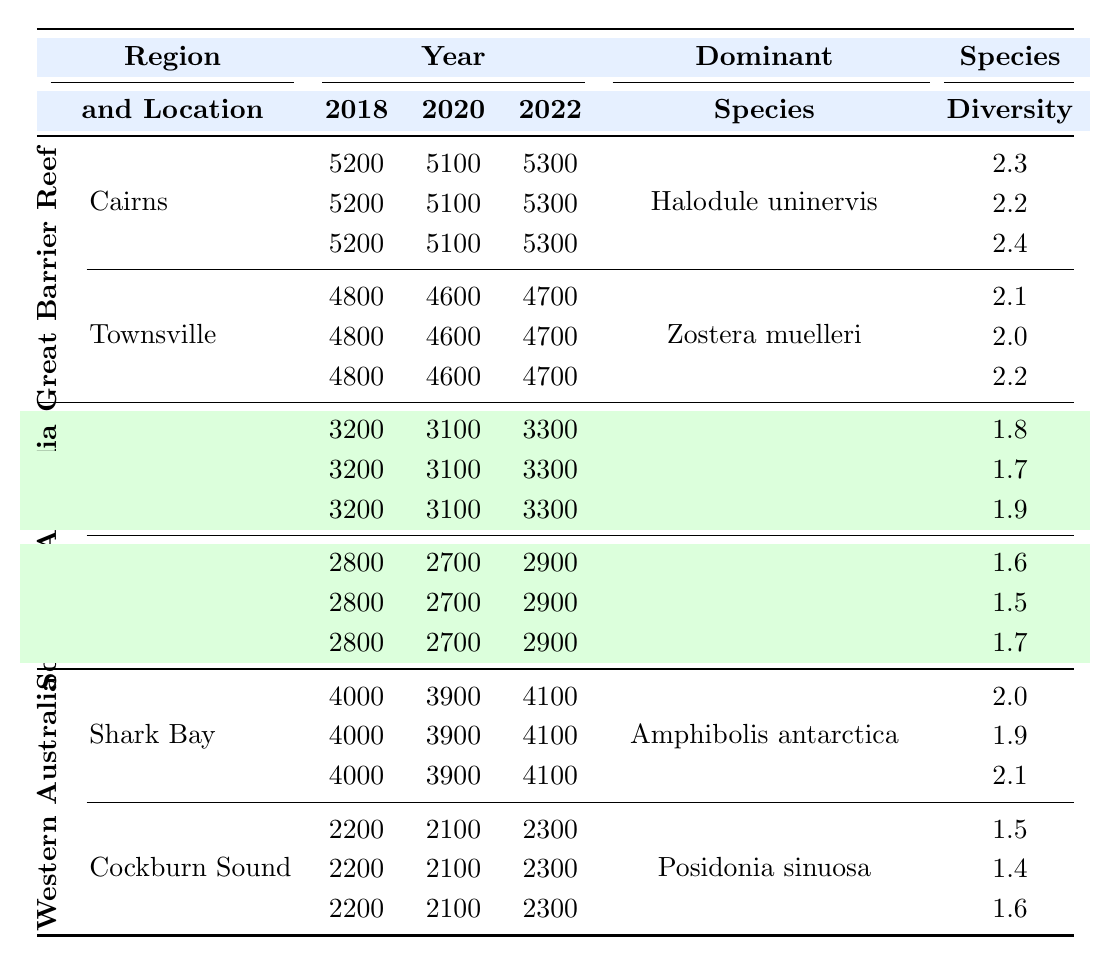What was the total coverage of seagrass in Cairns in 2022? The table shows that in Cairns, the total coverage of seagrass in 2022 was 5300 hectares.
Answer: 5300 hectares Which location had the highest species diversity index in 2020? By comparing the Species Diversity Index values listed for each location in 2020, Townsville had a value of 2.0, which is higher than Port Phillip Bay's 1.7 and Gulf St Vincent's 1.5. Therefore, Townsville had the highest species diversity index in 2020.
Answer: Townsville Is Halodule uninervis the dominant species in both Cairns and Townsville? The table indicates that Halodule uninervis is the dominant species in Cairns, but in Townsville, the dominant species is Zostera muelleri. Therefore, it is not true that Halodule uninervis is the dominant species in both locations.
Answer: No What is the average total coverage of seagrass in Shark Bay over the years surveyed? To find the average, sum the total coverage over the three years: 4000 + 3900 + 4100 = 12000. Then divide by the number of years (3): 12000 / 3 = 4000.
Answer: 4000 hectares How did the Species Diversity Index change from 2018 to 2022 in Port Phillip Bay? In 2018, the Species Diversity Index for Port Phillip Bay was 1.8. In 2022, it increased to 1.9. Hence, there is an increase of 0.1 over the period from 2018 to 2022.
Answer: Increased by 0.1 Which region experienced the greatest decrease in total seagrass coverage from 2018 to 2020? Looking at the table, the coverage for Southern Australia's Gulf St Vincent decreased from 2800 hectares in 2018 to 2700 hectares in 2020, resulting in a decrease of 100 hectares. This is more than the 100 hectares decrease in Cairns and Townsville, leading to the conclusion that Gulf St Vincent had the greatest decrease in total coverage.
Answer: Gulf St Vincent What can be inferred about the trends in total coverage of seagrass in Great Barrier Reef locations from 2018 to 2022? Examining the total coverage in Cairns and Townsville, Cairns showed a slight decline from 5200 hectares in 2018 to 5100 hectares in 2020 before increasing to 5300 hectares in 2022. Townsville consistently declined from 4800 hectares in 2018 to 4600 hectares in 2020, then slightly recovered to 4700 hectares in 2022. Overall, Cairns shows an upward trend while Townsville shows some recovery after a decline.
Answer: Mixed trends: Cairns up; Townsville slight recovery Is there a correlation between the dominant species and the species diversity index in the regions surveyed? To determine this correlation, we compare the dominant species to their respective Species Diversity Index values. Despite different dominant species in different locations, all values are relatively low (ranging from 1.5 to 2.4), indicating no clear correlation can be drawn. Hence, a definitive correlation is not supported by the data.
Answer: No clear correlation 